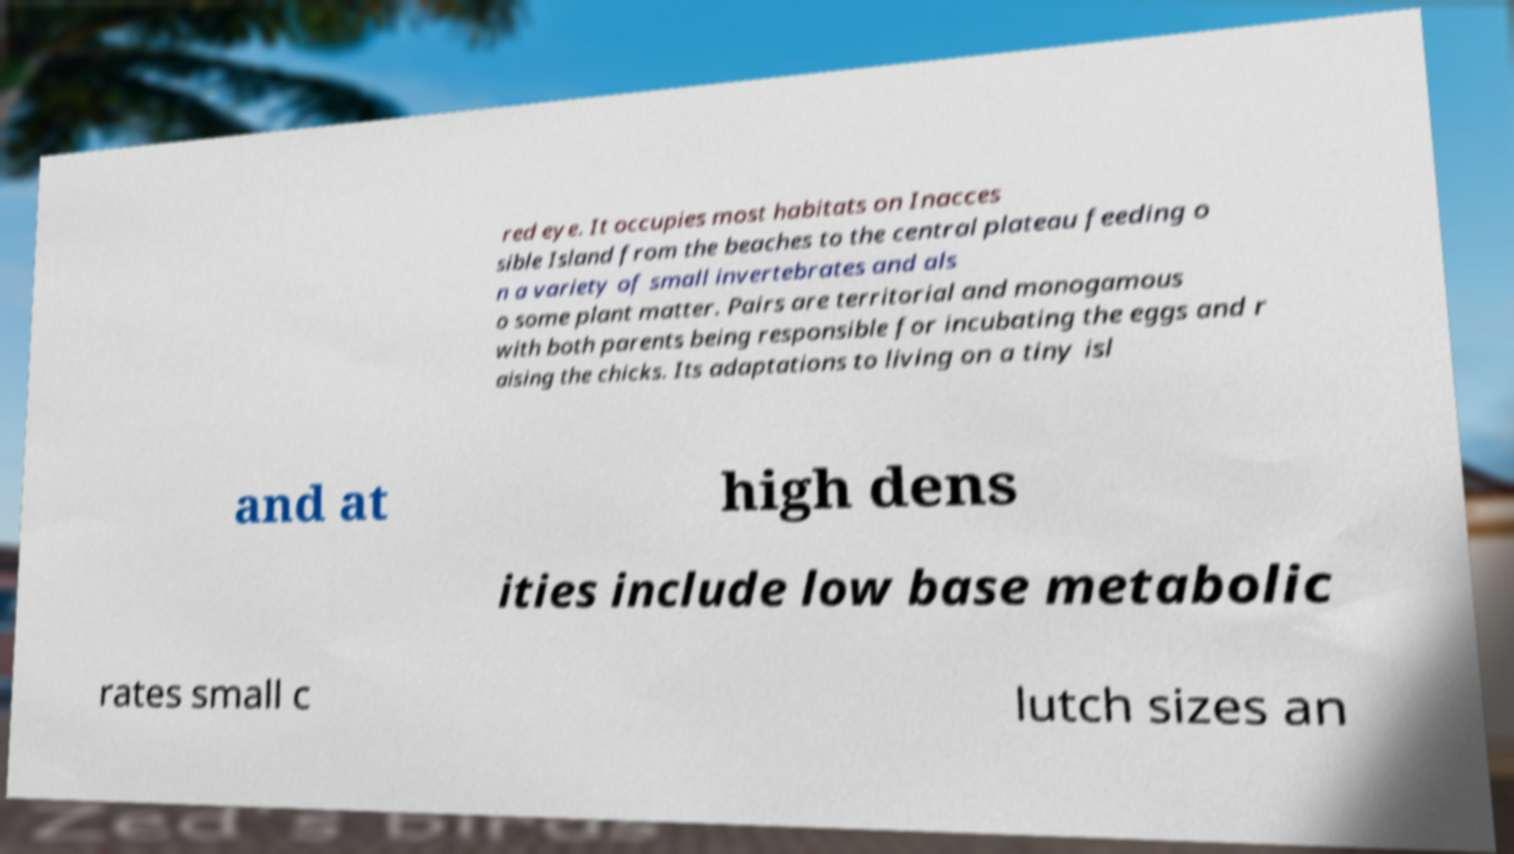What messages or text are displayed in this image? I need them in a readable, typed format. red eye. It occupies most habitats on Inacces sible Island from the beaches to the central plateau feeding o n a variety of small invertebrates and als o some plant matter. Pairs are territorial and monogamous with both parents being responsible for incubating the eggs and r aising the chicks. Its adaptations to living on a tiny isl and at high dens ities include low base metabolic rates small c lutch sizes an 